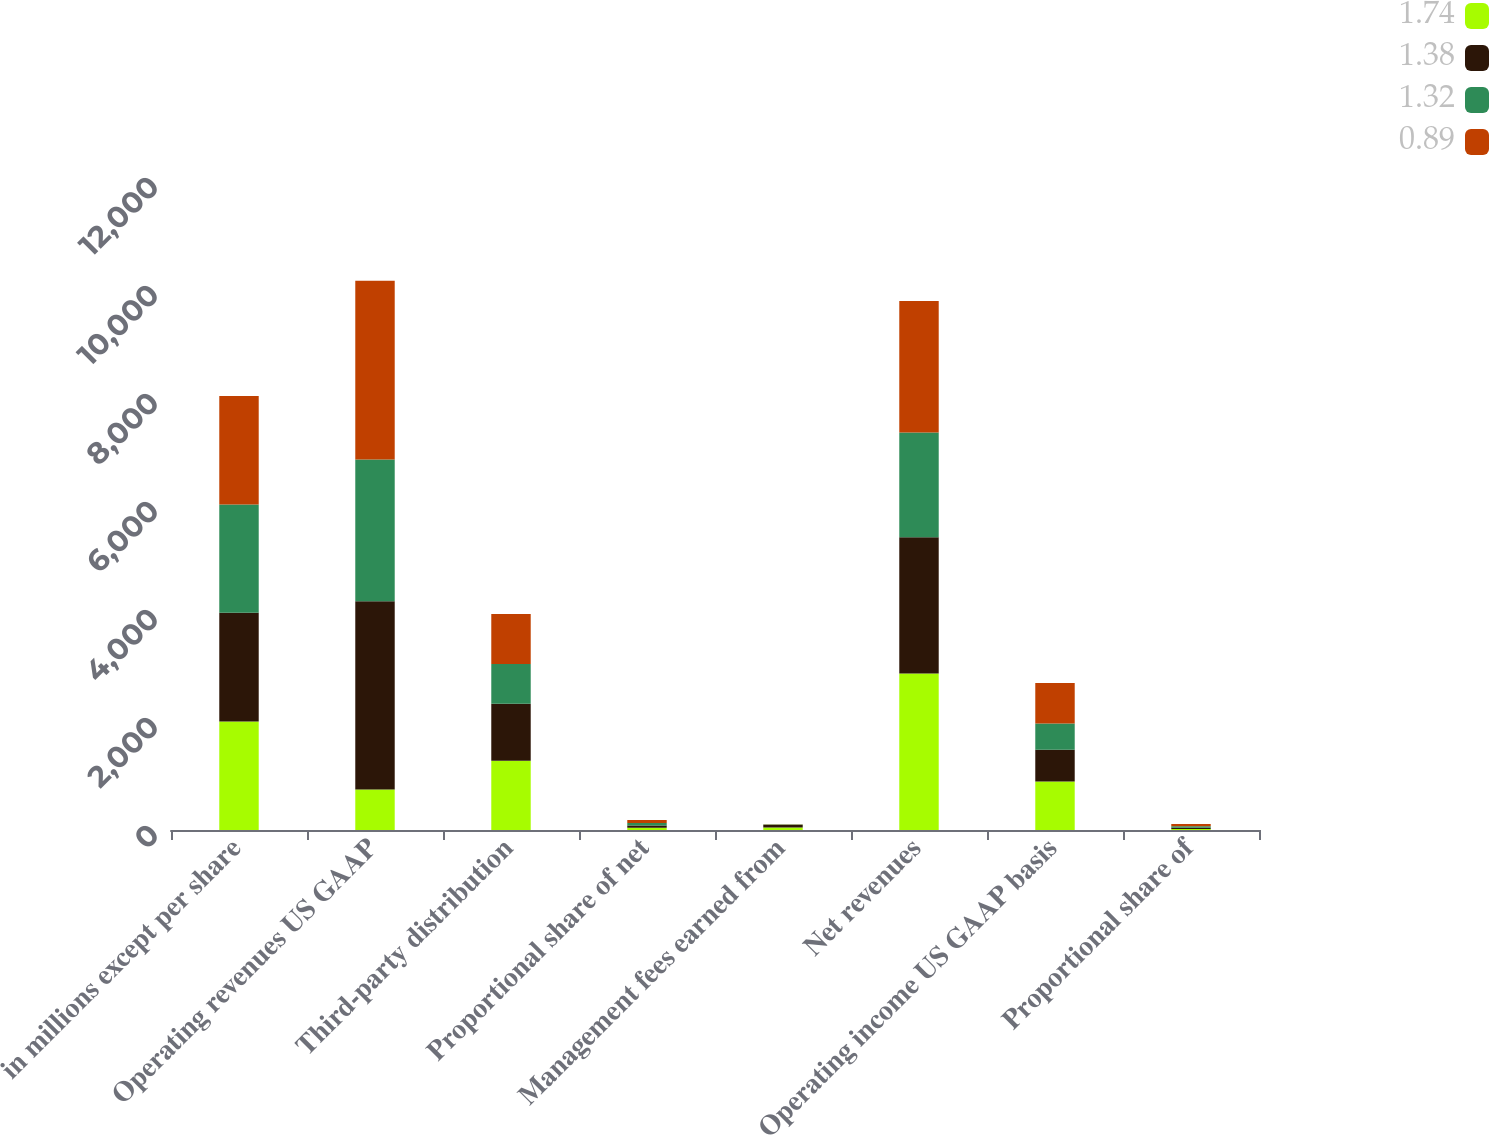Convert chart. <chart><loc_0><loc_0><loc_500><loc_500><stacked_bar_chart><ecel><fcel>in millions except per share<fcel>Operating revenues US GAAP<fcel>Third-party distribution<fcel>Proportional share of net<fcel>Management fees earned from<fcel>Net revenues<fcel>Operating income US GAAP basis<fcel>Proportional share of<nl><fcel>1.74<fcel>2011<fcel>747.8<fcel>1282.5<fcel>41.4<fcel>46.8<fcel>2898.4<fcel>898.1<fcel>19.2<nl><fcel>1.38<fcel>2010<fcel>3487.7<fcel>1053.8<fcel>42.2<fcel>45.3<fcel>2521.1<fcel>589.9<fcel>22.9<nl><fcel>1.32<fcel>2009<fcel>2627.3<fcel>737<fcel>44.7<fcel>8<fcel>1941<fcel>484.3<fcel>28.4<nl><fcel>0.89<fcel>2008<fcel>3307.6<fcel>927.8<fcel>57.3<fcel>6.2<fcel>2437.9<fcel>747.8<fcel>39.7<nl></chart> 